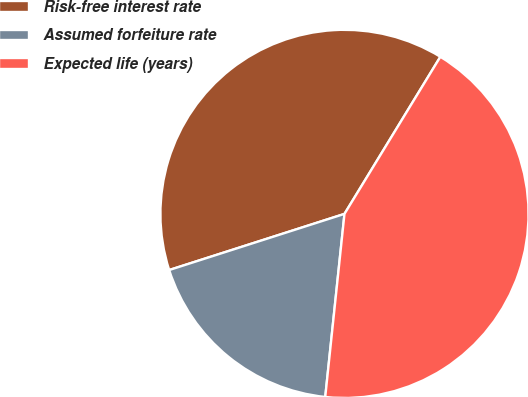<chart> <loc_0><loc_0><loc_500><loc_500><pie_chart><fcel>Risk-free interest rate<fcel>Assumed forfeiture rate<fcel>Expected life (years)<nl><fcel>38.65%<fcel>18.4%<fcel>42.94%<nl></chart> 